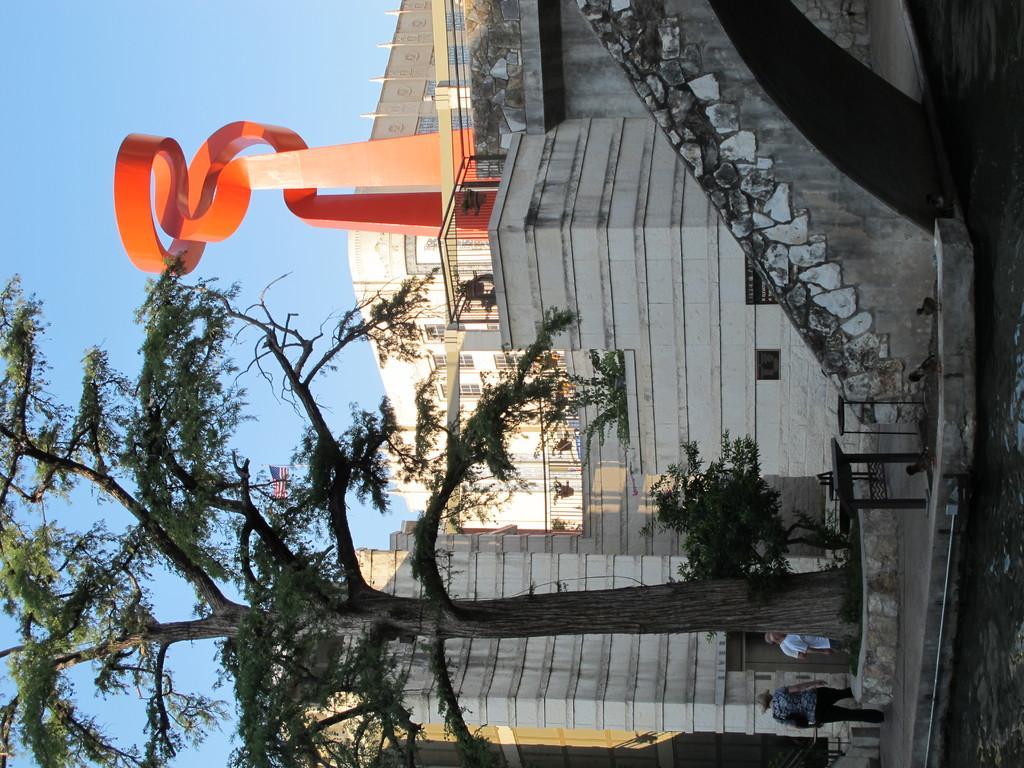How would you summarize this image in a sentence or two? In this picture there is a house in the center of the image and there is a tree at the bottom side of the image. 